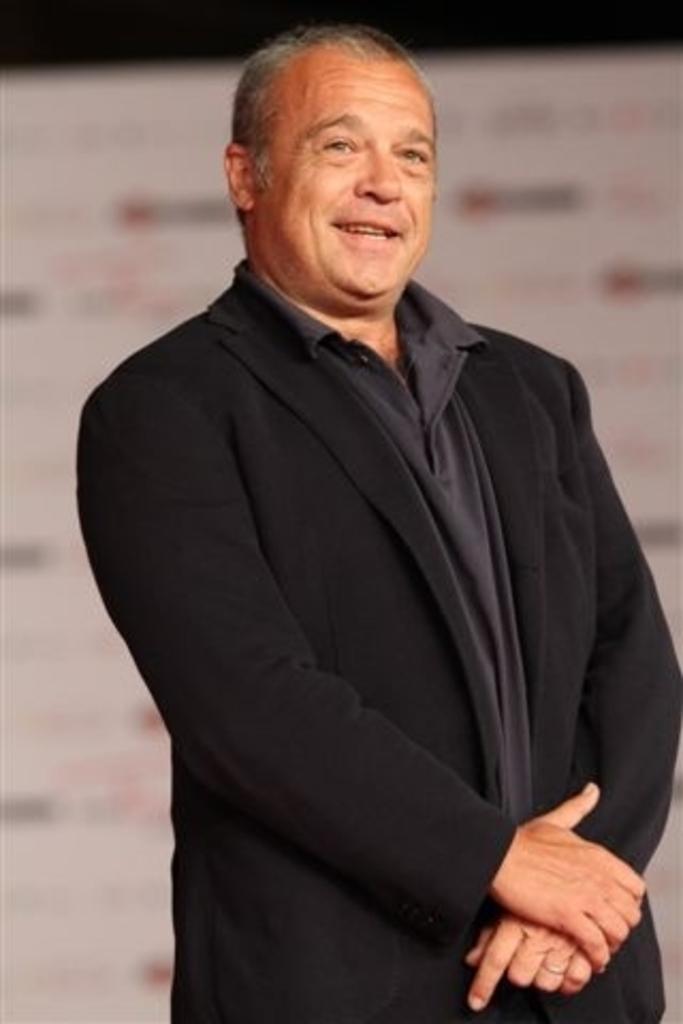Could you give a brief overview of what you see in this image? In this image I can see a man wearing black color suit, standing and smiling. The background is blurred. 